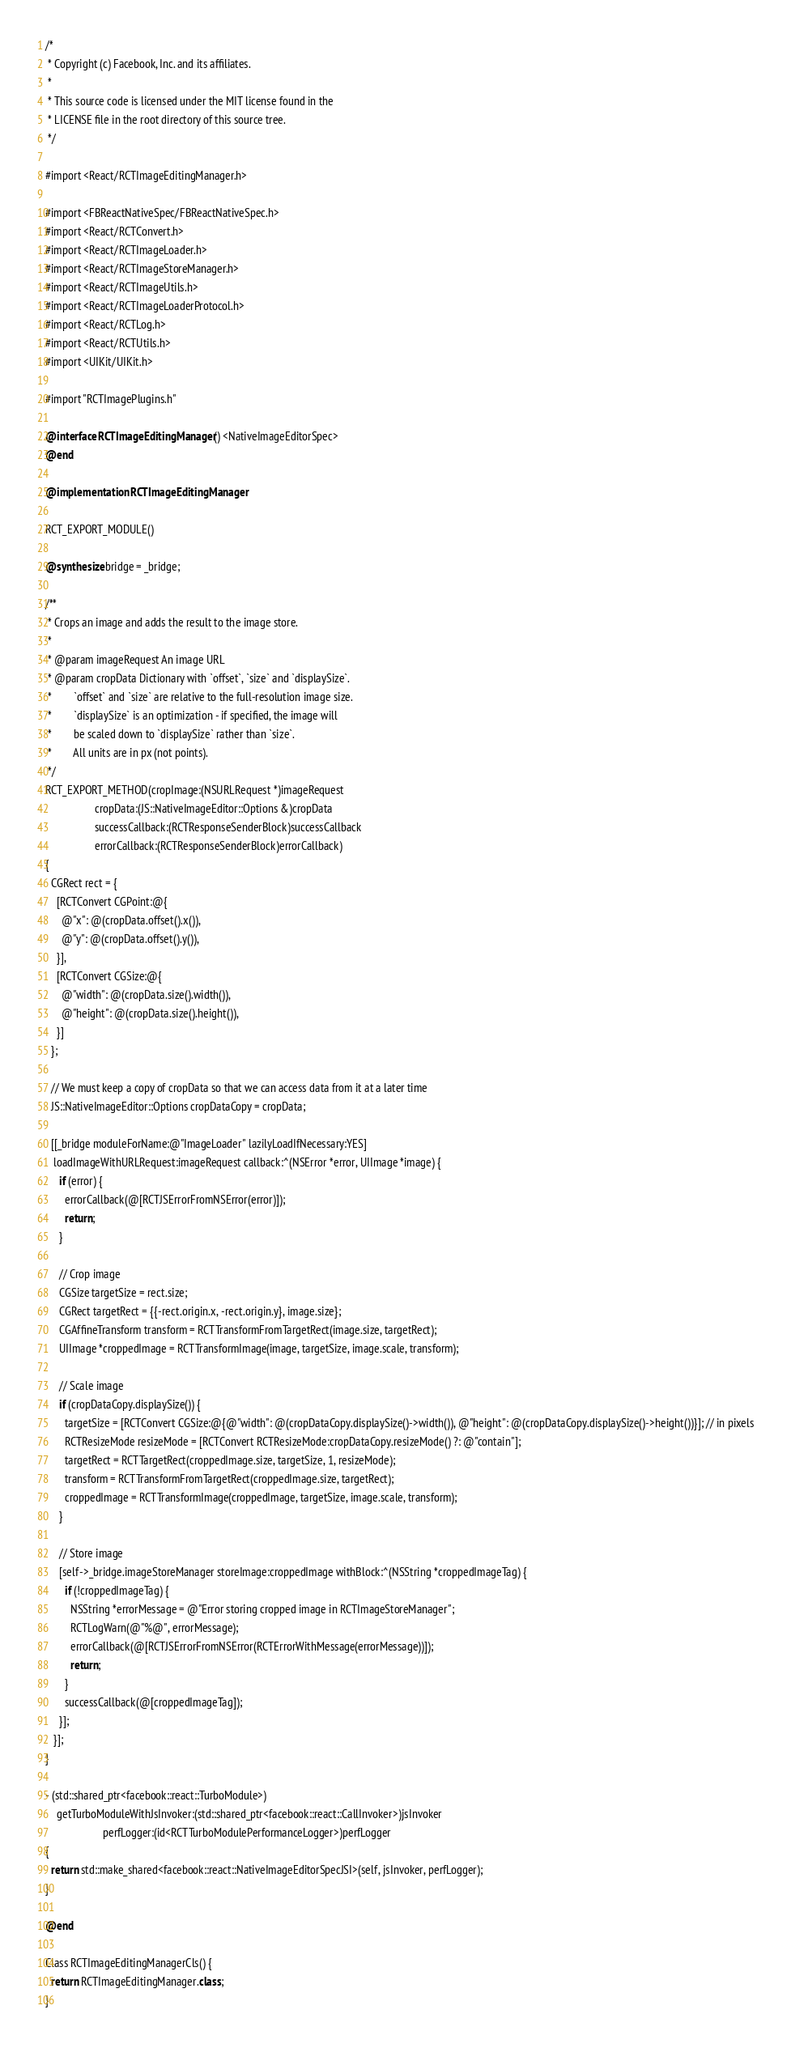Convert code to text. <code><loc_0><loc_0><loc_500><loc_500><_ObjectiveC_>/*
 * Copyright (c) Facebook, Inc. and its affiliates.
 *
 * This source code is licensed under the MIT license found in the
 * LICENSE file in the root directory of this source tree.
 */

#import <React/RCTImageEditingManager.h>

#import <FBReactNativeSpec/FBReactNativeSpec.h>
#import <React/RCTConvert.h>
#import <React/RCTImageLoader.h>
#import <React/RCTImageStoreManager.h>
#import <React/RCTImageUtils.h>
#import <React/RCTImageLoaderProtocol.h>
#import <React/RCTLog.h>
#import <React/RCTUtils.h>
#import <UIKit/UIKit.h>

#import "RCTImagePlugins.h"

@interface RCTImageEditingManager() <NativeImageEditorSpec>
@end

@implementation RCTImageEditingManager

RCT_EXPORT_MODULE()

@synthesize bridge = _bridge;

/**
 * Crops an image and adds the result to the image store.
 *
 * @param imageRequest An image URL
 * @param cropData Dictionary with `offset`, `size` and `displaySize`.
 *        `offset` and `size` are relative to the full-resolution image size.
 *        `displaySize` is an optimization - if specified, the image will
 *        be scaled down to `displaySize` rather than `size`.
 *        All units are in px (not points).
 */
RCT_EXPORT_METHOD(cropImage:(NSURLRequest *)imageRequest
                  cropData:(JS::NativeImageEditor::Options &)cropData
                  successCallback:(RCTResponseSenderBlock)successCallback
                  errorCallback:(RCTResponseSenderBlock)errorCallback)
{
  CGRect rect = {
    [RCTConvert CGPoint:@{
      @"x": @(cropData.offset().x()),
      @"y": @(cropData.offset().y()),
    }],
    [RCTConvert CGSize:@{
      @"width": @(cropData.size().width()),
      @"height": @(cropData.size().height()),
    }]
  };
  
  // We must keep a copy of cropData so that we can access data from it at a later time
  JS::NativeImageEditor::Options cropDataCopy = cropData;

  [[_bridge moduleForName:@"ImageLoader" lazilyLoadIfNecessary:YES]
   loadImageWithURLRequest:imageRequest callback:^(NSError *error, UIImage *image) {
     if (error) {
       errorCallback(@[RCTJSErrorFromNSError(error)]);
       return;
     }

     // Crop image
     CGSize targetSize = rect.size;
     CGRect targetRect = {{-rect.origin.x, -rect.origin.y}, image.size};
     CGAffineTransform transform = RCTTransformFromTargetRect(image.size, targetRect);
     UIImage *croppedImage = RCTTransformImage(image, targetSize, image.scale, transform);

     // Scale image
     if (cropDataCopy.displaySize()) {
       targetSize = [RCTConvert CGSize:@{@"width": @(cropDataCopy.displaySize()->width()), @"height": @(cropDataCopy.displaySize()->height())}]; // in pixels
       RCTResizeMode resizeMode = [RCTConvert RCTResizeMode:cropDataCopy.resizeMode() ?: @"contain"];
       targetRect = RCTTargetRect(croppedImage.size, targetSize, 1, resizeMode);
       transform = RCTTransformFromTargetRect(croppedImage.size, targetRect);
       croppedImage = RCTTransformImage(croppedImage, targetSize, image.scale, transform);
     }

     // Store image
     [self->_bridge.imageStoreManager storeImage:croppedImage withBlock:^(NSString *croppedImageTag) {
       if (!croppedImageTag) {
         NSString *errorMessage = @"Error storing cropped image in RCTImageStoreManager";
         RCTLogWarn(@"%@", errorMessage);
         errorCallback(@[RCTJSErrorFromNSError(RCTErrorWithMessage(errorMessage))]);
         return;
       }
       successCallback(@[croppedImageTag]);
     }];
   }];
}

- (std::shared_ptr<facebook::react::TurboModule>)
    getTurboModuleWithJsInvoker:(std::shared_ptr<facebook::react::CallInvoker>)jsInvoker
                     perfLogger:(id<RCTTurboModulePerformanceLogger>)perfLogger
{
  return std::make_shared<facebook::react::NativeImageEditorSpecJSI>(self, jsInvoker, perfLogger);
}

@end

Class RCTImageEditingManagerCls() {
  return RCTImageEditingManager.class;
}
</code> 